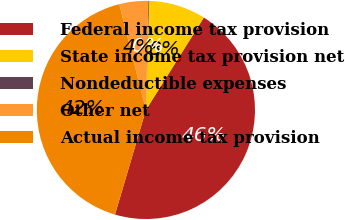Convert chart to OTSL. <chart><loc_0><loc_0><loc_500><loc_500><pie_chart><fcel>Federal income tax provision<fcel>State income tax provision net<fcel>Nondeductible expenses<fcel>Other net<fcel>Actual income tax provision<nl><fcel>45.66%<fcel>8.44%<fcel>0.12%<fcel>4.28%<fcel>41.5%<nl></chart> 